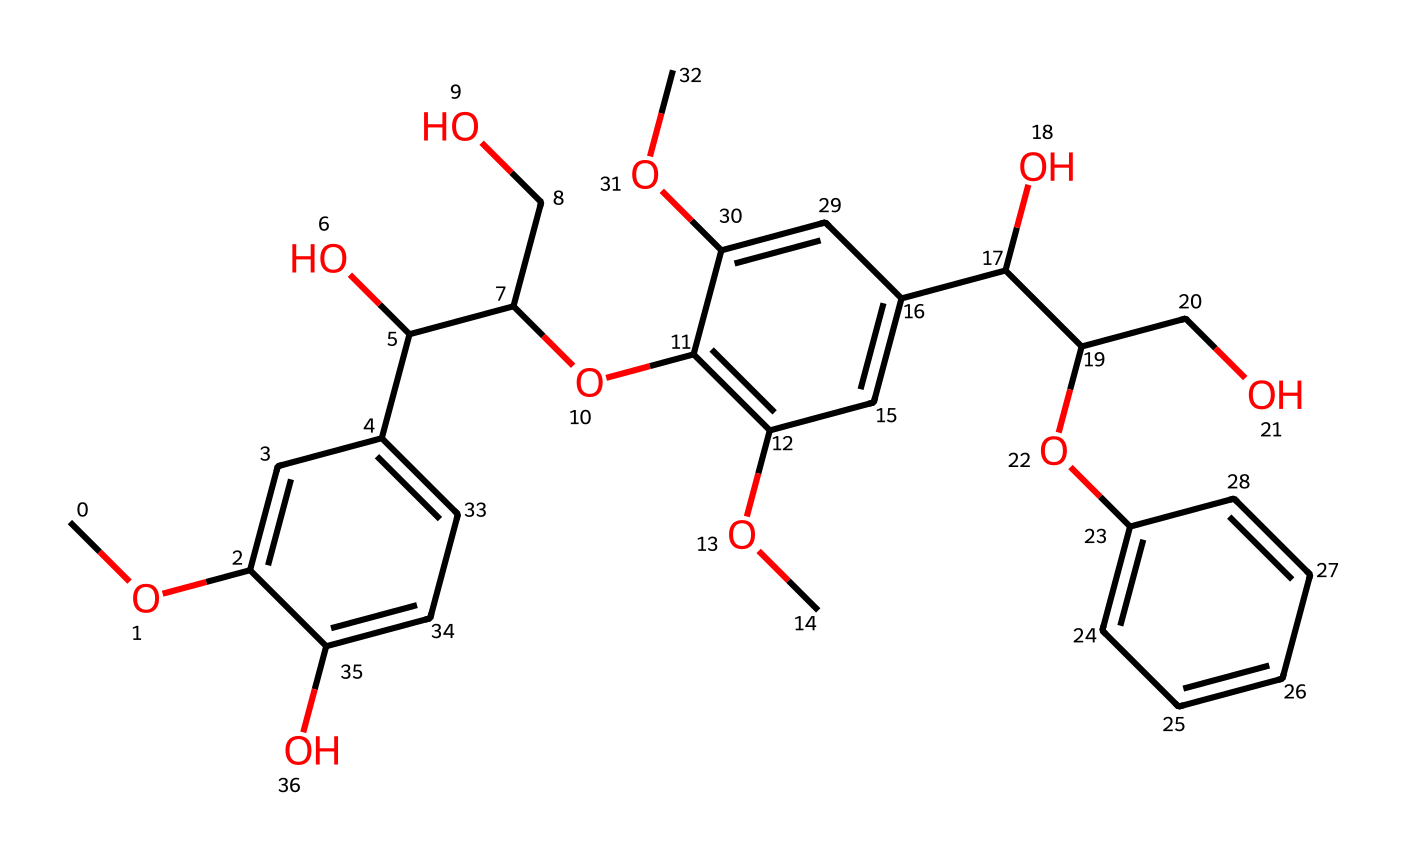how many carbon atoms are in the structure? Count the carbon (C) atoms represented in the SMILES notation. Each 'C' indicates a carbon atom, and through analyzing the structure, a total of 23 carbon atoms can be tallied.
Answer: 23 what functional groups are present in this chemical? Examine the functional groups identifiable in the chemical’s structure; hydroxyl (-OH) and ether (R-O-R') groups can be noted. The presence of alkoxy groups (like -O-) suggests ether functionality.
Answer: hydroxyl and ether what is the degree of substitution at the aromatic rings? Analyze the aromatic rings in the chemical structure. Each ring has substituents (such as -OH and -O-) attached; here, the phenolic recognition indicates a higher degree of substitution. The analysis shows multiple substituents per ring.
Answer: high does this compound exhibit any stereochemistry? Review the structure for chiral centers, which are typically represented by carbon atoms bonded to four distinct groups. However, after analyzing the carbon atoms, it is determined that no center fits this criterion.
Answer: no what is the primary type of reaction aldehydes undergo? Aldehydes typically undergo oxidation reactions yielding carboxylic acids. Reference the presence of the aldehyde group (-CHO) in the structure which directs this behavior during organic reactions.
Answer: oxidation 